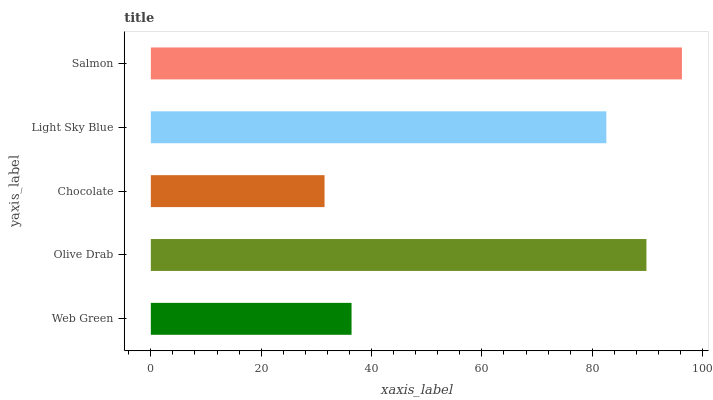Is Chocolate the minimum?
Answer yes or no. Yes. Is Salmon the maximum?
Answer yes or no. Yes. Is Olive Drab the minimum?
Answer yes or no. No. Is Olive Drab the maximum?
Answer yes or no. No. Is Olive Drab greater than Web Green?
Answer yes or no. Yes. Is Web Green less than Olive Drab?
Answer yes or no. Yes. Is Web Green greater than Olive Drab?
Answer yes or no. No. Is Olive Drab less than Web Green?
Answer yes or no. No. Is Light Sky Blue the high median?
Answer yes or no. Yes. Is Light Sky Blue the low median?
Answer yes or no. Yes. Is Web Green the high median?
Answer yes or no. No. Is Olive Drab the low median?
Answer yes or no. No. 